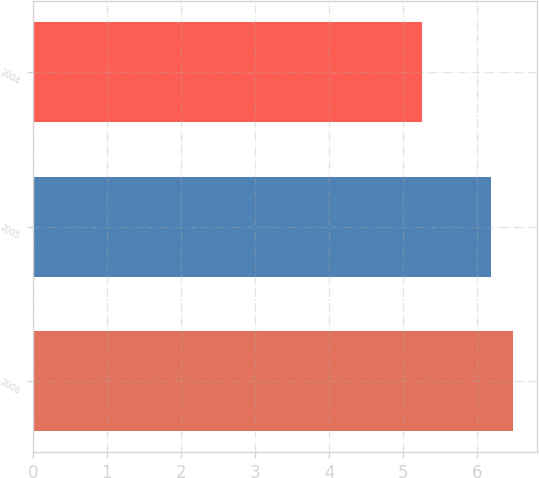<chart> <loc_0><loc_0><loc_500><loc_500><bar_chart><fcel>2006<fcel>2005<fcel>2004<nl><fcel>6.48<fcel>6.18<fcel>5.25<nl></chart> 